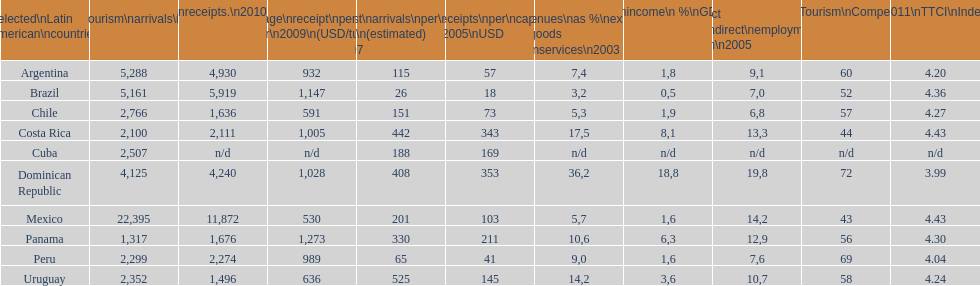Which country had the least amount of tourism income in 2003? Brazil. 